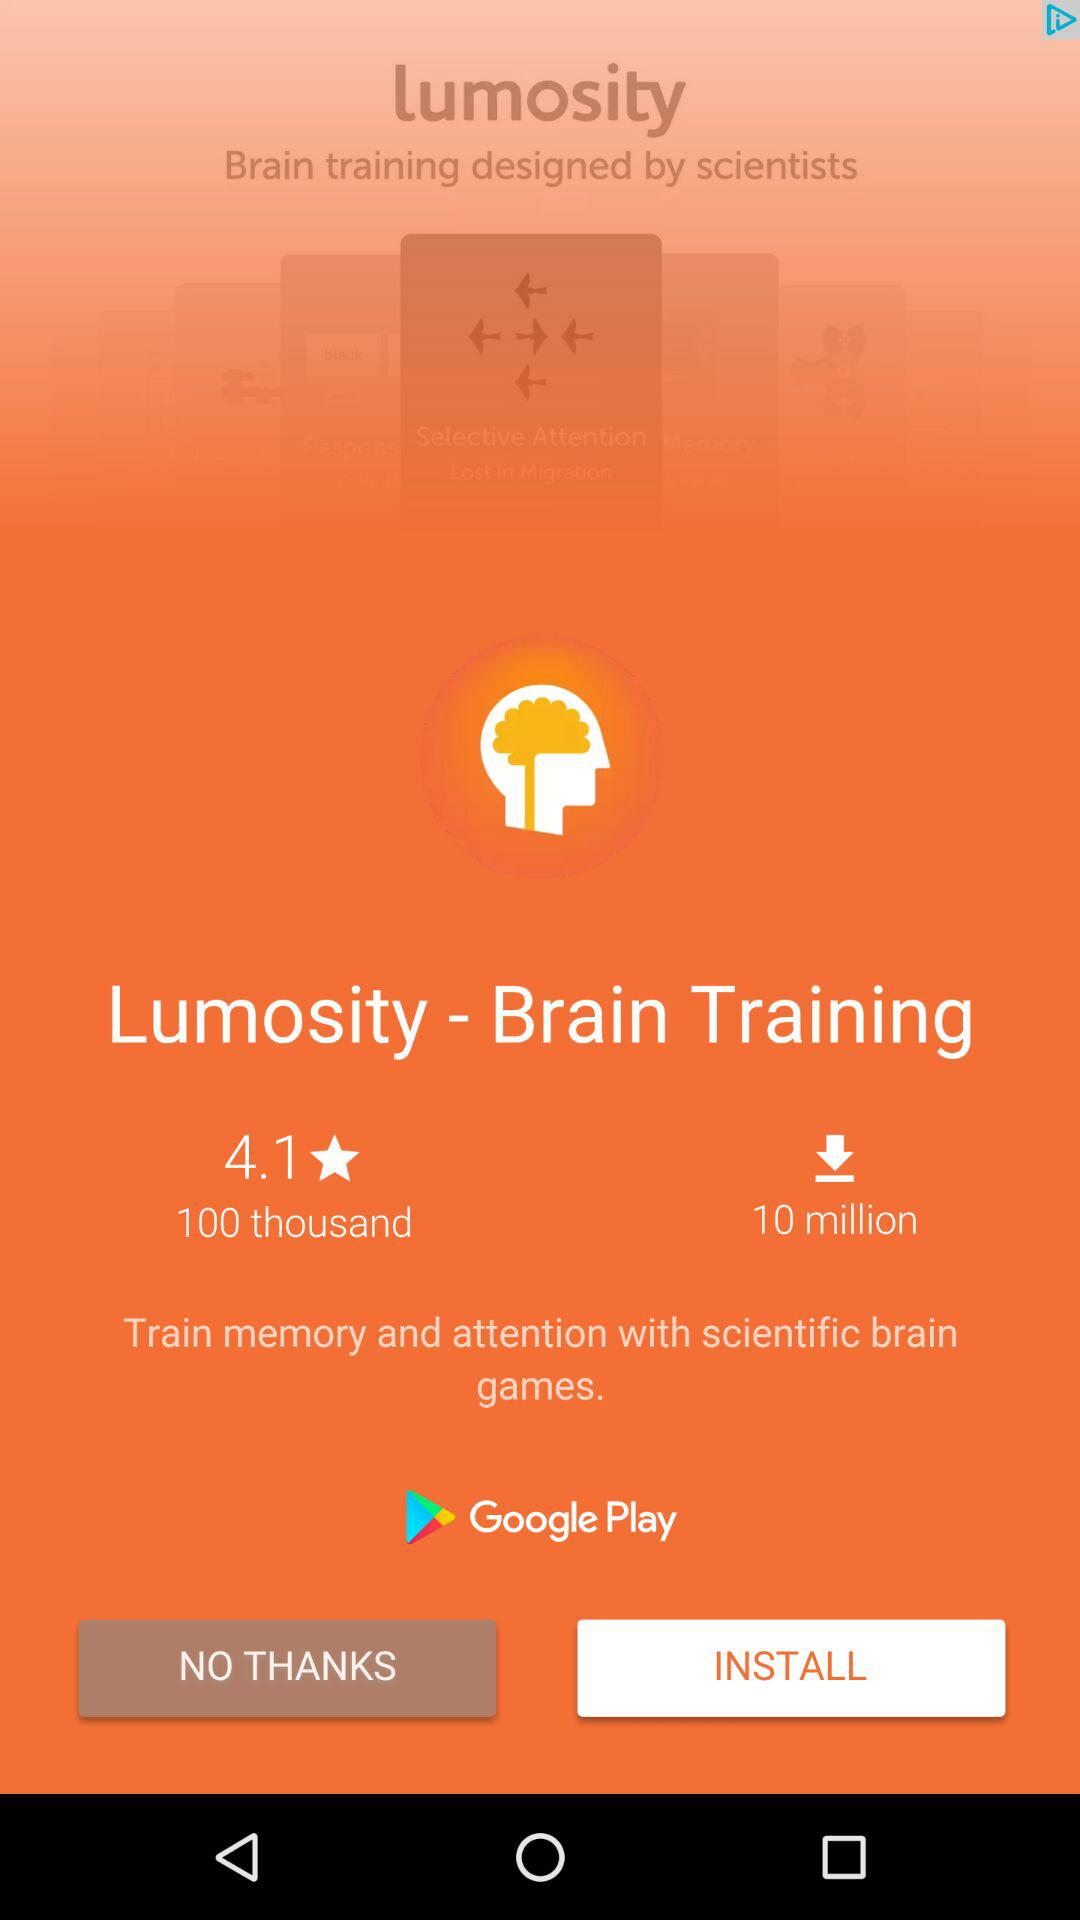How many more people have downloaded Lumosity than rated it?
Answer the question using a single word or phrase. 9 million 